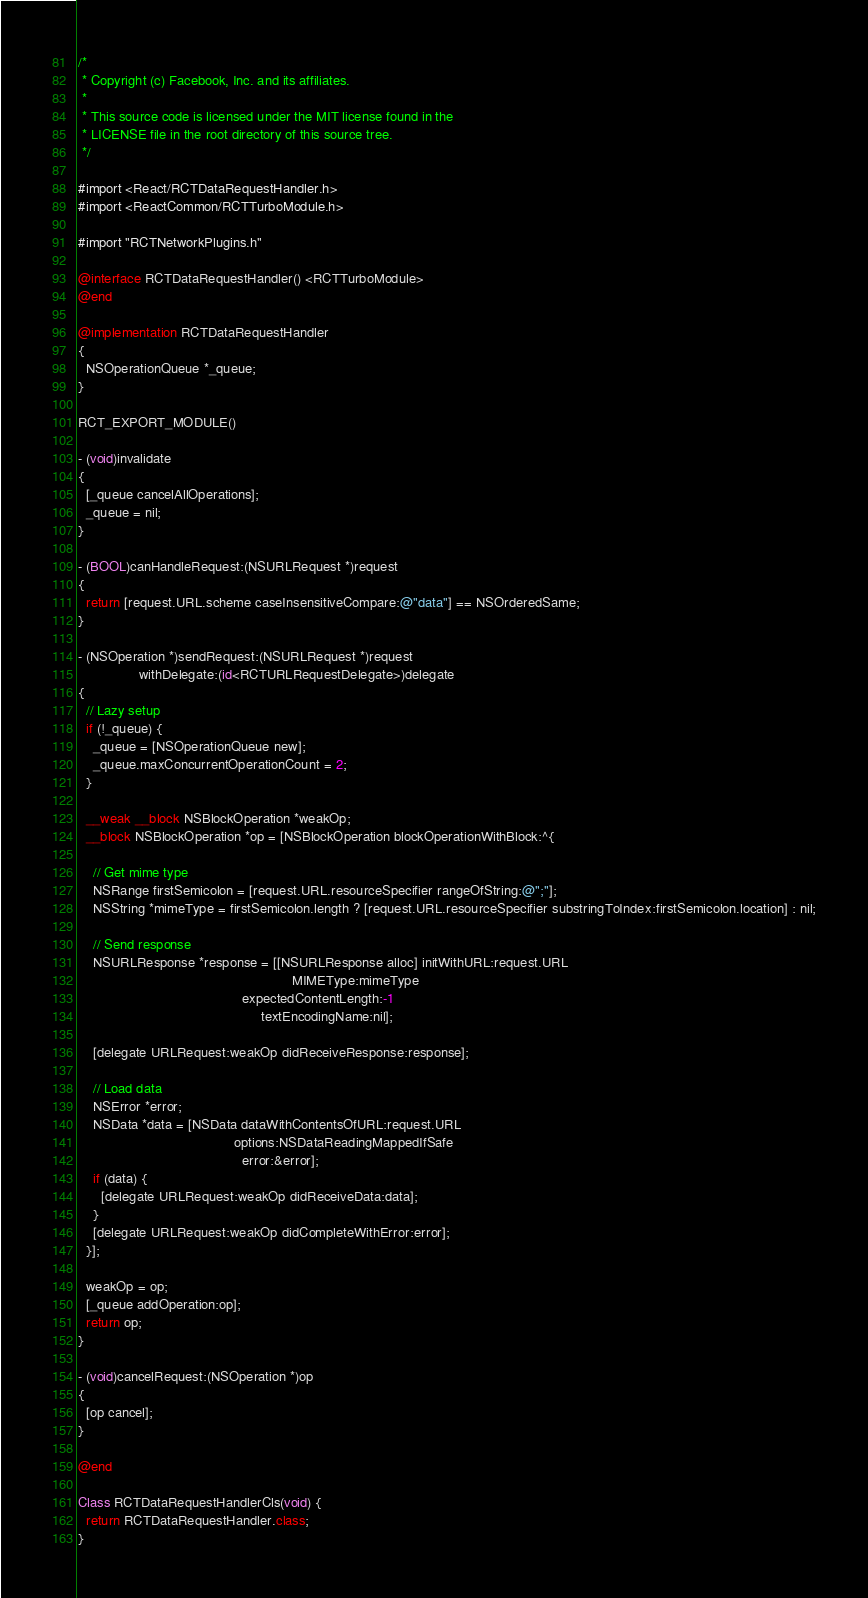<code> <loc_0><loc_0><loc_500><loc_500><_ObjectiveC_>/*
 * Copyright (c) Facebook, Inc. and its affiliates.
 *
 * This source code is licensed under the MIT license found in the
 * LICENSE file in the root directory of this source tree.
 */

#import <React/RCTDataRequestHandler.h>
#import <ReactCommon/RCTTurboModule.h>

#import "RCTNetworkPlugins.h"

@interface RCTDataRequestHandler() <RCTTurboModule>
@end

@implementation RCTDataRequestHandler
{
  NSOperationQueue *_queue;
}

RCT_EXPORT_MODULE()

- (void)invalidate
{
  [_queue cancelAllOperations];
  _queue = nil;
}

- (BOOL)canHandleRequest:(NSURLRequest *)request
{
  return [request.URL.scheme caseInsensitiveCompare:@"data"] == NSOrderedSame;
}

- (NSOperation *)sendRequest:(NSURLRequest *)request
                withDelegate:(id<RCTURLRequestDelegate>)delegate
{
  // Lazy setup
  if (!_queue) {
    _queue = [NSOperationQueue new];
    _queue.maxConcurrentOperationCount = 2;
  }

  __weak __block NSBlockOperation *weakOp;
  __block NSBlockOperation *op = [NSBlockOperation blockOperationWithBlock:^{

    // Get mime type
    NSRange firstSemicolon = [request.URL.resourceSpecifier rangeOfString:@";"];
    NSString *mimeType = firstSemicolon.length ? [request.URL.resourceSpecifier substringToIndex:firstSemicolon.location] : nil;

    // Send response
    NSURLResponse *response = [[NSURLResponse alloc] initWithURL:request.URL
                                                        MIMEType:mimeType
                                           expectedContentLength:-1
                                                textEncodingName:nil];

    [delegate URLRequest:weakOp didReceiveResponse:response];

    // Load data
    NSError *error;
    NSData *data = [NSData dataWithContentsOfURL:request.URL
                                         options:NSDataReadingMappedIfSafe
                                           error:&error];
    if (data) {
      [delegate URLRequest:weakOp didReceiveData:data];
    }
    [delegate URLRequest:weakOp didCompleteWithError:error];
  }];

  weakOp = op;
  [_queue addOperation:op];
  return op;
}

- (void)cancelRequest:(NSOperation *)op
{
  [op cancel];
}

@end

Class RCTDataRequestHandlerCls(void) {
  return RCTDataRequestHandler.class;
}
</code> 